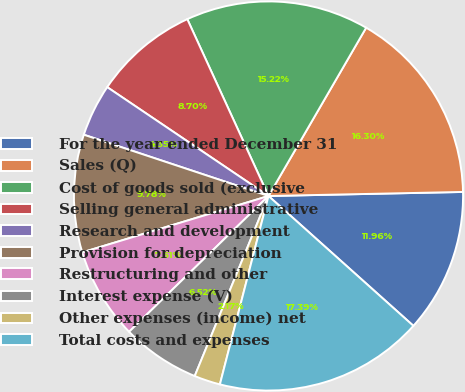Convert chart. <chart><loc_0><loc_0><loc_500><loc_500><pie_chart><fcel>For the year ended December 31<fcel>Sales (Q)<fcel>Cost of goods sold (exclusive<fcel>Selling general administrative<fcel>Research and development<fcel>Provision for depreciation<fcel>Restructuring and other<fcel>Interest expense (V)<fcel>Other expenses (income) net<fcel>Total costs and expenses<nl><fcel>11.96%<fcel>16.3%<fcel>15.22%<fcel>8.7%<fcel>4.35%<fcel>9.78%<fcel>7.61%<fcel>6.52%<fcel>2.17%<fcel>17.39%<nl></chart> 